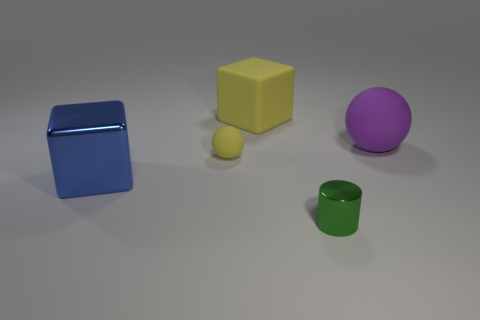Add 1 gray metallic cylinders. How many objects exist? 6 Subtract 1 cubes. How many cubes are left? 1 Subtract all spheres. How many objects are left? 3 Subtract 0 green cubes. How many objects are left? 5 Subtract all red cylinders. Subtract all gray cubes. How many cylinders are left? 1 Subtract all purple cylinders. How many cyan blocks are left? 0 Subtract all small yellow matte balls. Subtract all rubber cubes. How many objects are left? 3 Add 4 blue metallic things. How many blue metallic things are left? 5 Add 5 yellow balls. How many yellow balls exist? 6 